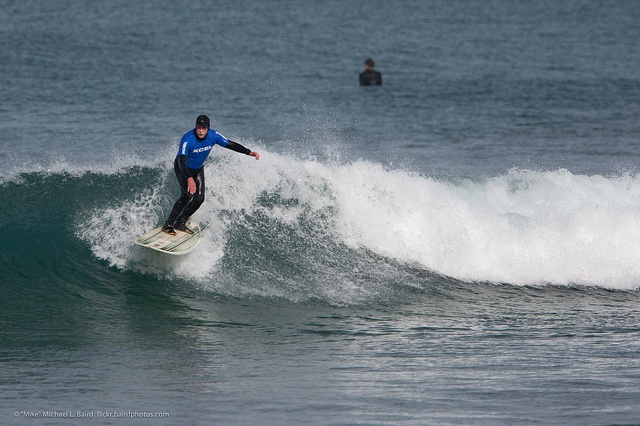Describe the objects in this image and their specific colors. I can see people in gray, black, navy, blue, and darkblue tones, surfboard in gray, darkgray, lightgray, and tan tones, and people in gray, black, and blue tones in this image. 